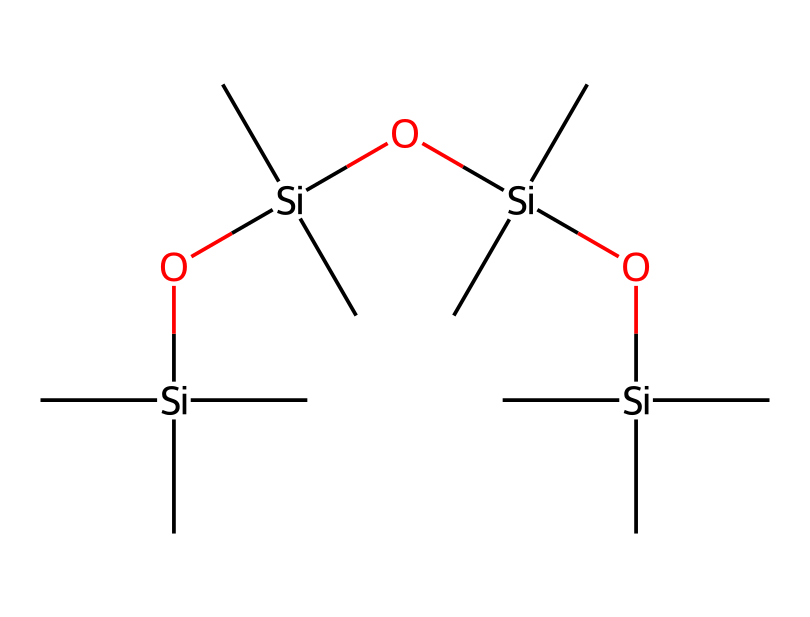what is the central atom in this chemical? The central atom in this chemical is silicon, which is denoted by the symbol 'Si' in the SMILES representation. Each occurrence of '[Si]' indicates a silicon atom present in the structure.
Answer: silicon how many silicon atoms are in the structure? By counting the occurrences of '[Si]' in the SMILES representation, we can see there are four silicon atoms present.
Answer: four what type of bonds are present in this chemical structure? The structure contains silicon-oxygen (Si-O) bonds, as shown by the 'O' in between the 'Si' atoms in the SMILES. It also contains silicon-carbon (Si-C) bonds, indicated by the ''C''s attached to the silicon atoms.
Answer: Si-O and Si-C what functional groups are present in this molecular composition? The main functional group present is the siloxane group (Si-O-Si), which is characterized by the repeating silicon and oxygen atoms in the structure.
Answer: siloxane how many carbon atoms are attached to each silicon atom? Each silicon atom in this structure is bonded to three carbon atoms, as indicated by the three '(C)' connected to each '[Si]' in the SMILES.
Answer: three which property makes this lubricant suitable for medical use? The chemical stability and low reactivity of silicone-based lubricants, due to their siloxane backbone, contribute to their suitability for medical applications.
Answer: stability is this lubricant hydrophobic or hydrophilic? Silicone-based lubricants are typically hydrophobic, meaning they repel water, which is due to their non-polar siloxane structures.
Answer: hydrophobic 